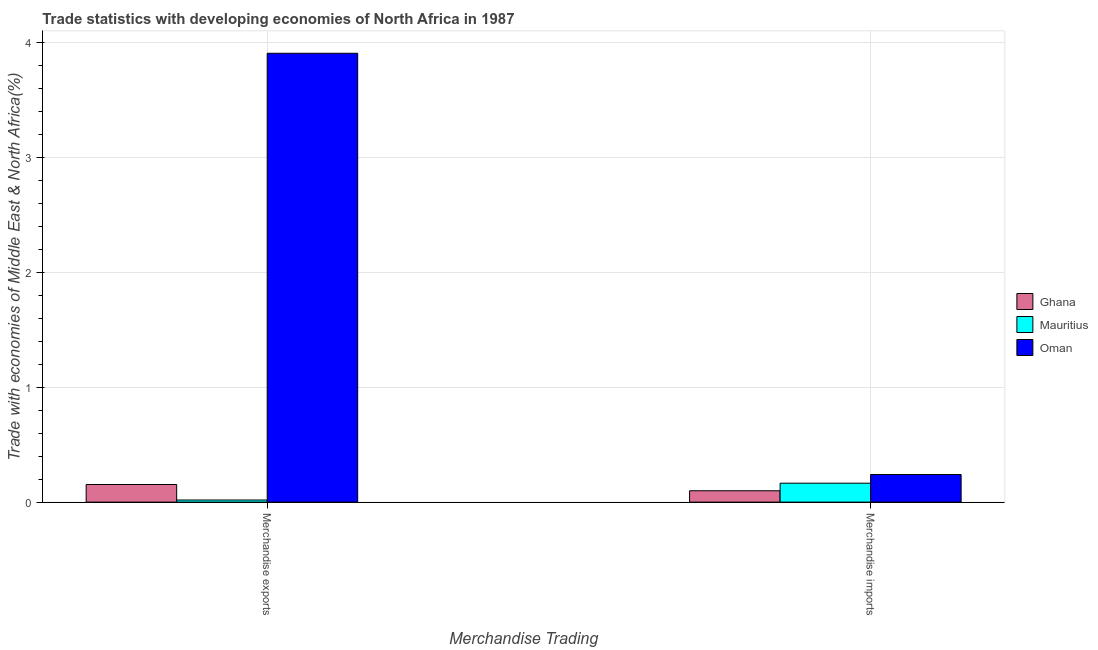How many different coloured bars are there?
Offer a very short reply. 3. Are the number of bars per tick equal to the number of legend labels?
Offer a terse response. Yes. Are the number of bars on each tick of the X-axis equal?
Keep it short and to the point. Yes. How many bars are there on the 1st tick from the left?
Provide a succinct answer. 3. How many bars are there on the 1st tick from the right?
Make the answer very short. 3. What is the merchandise imports in Oman?
Offer a terse response. 0.24. Across all countries, what is the maximum merchandise imports?
Keep it short and to the point. 0.24. Across all countries, what is the minimum merchandise exports?
Keep it short and to the point. 0.02. In which country was the merchandise imports maximum?
Keep it short and to the point. Oman. What is the total merchandise imports in the graph?
Ensure brevity in your answer.  0.5. What is the difference between the merchandise exports in Mauritius and that in Oman?
Offer a terse response. -3.89. What is the difference between the merchandise imports in Mauritius and the merchandise exports in Ghana?
Provide a succinct answer. 0.01. What is the average merchandise exports per country?
Offer a terse response. 1.36. What is the difference between the merchandise exports and merchandise imports in Ghana?
Provide a succinct answer. 0.05. What is the ratio of the merchandise exports in Mauritius to that in Oman?
Make the answer very short. 0. In how many countries, is the merchandise exports greater than the average merchandise exports taken over all countries?
Your response must be concise. 1. What does the 2nd bar from the left in Merchandise imports represents?
Your answer should be compact. Mauritius. What does the 1st bar from the right in Merchandise exports represents?
Give a very brief answer. Oman. How many bars are there?
Your response must be concise. 6. Are all the bars in the graph horizontal?
Keep it short and to the point. No. What is the difference between two consecutive major ticks on the Y-axis?
Make the answer very short. 1. Are the values on the major ticks of Y-axis written in scientific E-notation?
Offer a very short reply. No. How are the legend labels stacked?
Provide a succinct answer. Vertical. What is the title of the graph?
Ensure brevity in your answer.  Trade statistics with developing economies of North Africa in 1987. Does "Antigua and Barbuda" appear as one of the legend labels in the graph?
Give a very brief answer. No. What is the label or title of the X-axis?
Offer a terse response. Merchandise Trading. What is the label or title of the Y-axis?
Ensure brevity in your answer.  Trade with economies of Middle East & North Africa(%). What is the Trade with economies of Middle East & North Africa(%) in Ghana in Merchandise exports?
Your answer should be very brief. 0.15. What is the Trade with economies of Middle East & North Africa(%) of Mauritius in Merchandise exports?
Offer a very short reply. 0.02. What is the Trade with economies of Middle East & North Africa(%) in Oman in Merchandise exports?
Ensure brevity in your answer.  3.91. What is the Trade with economies of Middle East & North Africa(%) in Ghana in Merchandise imports?
Your answer should be compact. 0.1. What is the Trade with economies of Middle East & North Africa(%) in Mauritius in Merchandise imports?
Make the answer very short. 0.16. What is the Trade with economies of Middle East & North Africa(%) of Oman in Merchandise imports?
Your answer should be very brief. 0.24. Across all Merchandise Trading, what is the maximum Trade with economies of Middle East & North Africa(%) in Ghana?
Keep it short and to the point. 0.15. Across all Merchandise Trading, what is the maximum Trade with economies of Middle East & North Africa(%) in Mauritius?
Make the answer very short. 0.16. Across all Merchandise Trading, what is the maximum Trade with economies of Middle East & North Africa(%) in Oman?
Provide a succinct answer. 3.91. Across all Merchandise Trading, what is the minimum Trade with economies of Middle East & North Africa(%) of Ghana?
Keep it short and to the point. 0.1. Across all Merchandise Trading, what is the minimum Trade with economies of Middle East & North Africa(%) of Mauritius?
Offer a terse response. 0.02. Across all Merchandise Trading, what is the minimum Trade with economies of Middle East & North Africa(%) in Oman?
Offer a terse response. 0.24. What is the total Trade with economies of Middle East & North Africa(%) in Ghana in the graph?
Your answer should be compact. 0.25. What is the total Trade with economies of Middle East & North Africa(%) in Mauritius in the graph?
Keep it short and to the point. 0.18. What is the total Trade with economies of Middle East & North Africa(%) in Oman in the graph?
Offer a terse response. 4.15. What is the difference between the Trade with economies of Middle East & North Africa(%) in Ghana in Merchandise exports and that in Merchandise imports?
Your answer should be compact. 0.05. What is the difference between the Trade with economies of Middle East & North Africa(%) in Mauritius in Merchandise exports and that in Merchandise imports?
Offer a terse response. -0.15. What is the difference between the Trade with economies of Middle East & North Africa(%) of Oman in Merchandise exports and that in Merchandise imports?
Keep it short and to the point. 3.67. What is the difference between the Trade with economies of Middle East & North Africa(%) in Ghana in Merchandise exports and the Trade with economies of Middle East & North Africa(%) in Mauritius in Merchandise imports?
Provide a succinct answer. -0.01. What is the difference between the Trade with economies of Middle East & North Africa(%) in Ghana in Merchandise exports and the Trade with economies of Middle East & North Africa(%) in Oman in Merchandise imports?
Offer a terse response. -0.09. What is the difference between the Trade with economies of Middle East & North Africa(%) of Mauritius in Merchandise exports and the Trade with economies of Middle East & North Africa(%) of Oman in Merchandise imports?
Your answer should be very brief. -0.22. What is the average Trade with economies of Middle East & North Africa(%) of Ghana per Merchandise Trading?
Keep it short and to the point. 0.13. What is the average Trade with economies of Middle East & North Africa(%) in Mauritius per Merchandise Trading?
Keep it short and to the point. 0.09. What is the average Trade with economies of Middle East & North Africa(%) of Oman per Merchandise Trading?
Give a very brief answer. 2.07. What is the difference between the Trade with economies of Middle East & North Africa(%) in Ghana and Trade with economies of Middle East & North Africa(%) in Mauritius in Merchandise exports?
Ensure brevity in your answer.  0.14. What is the difference between the Trade with economies of Middle East & North Africa(%) in Ghana and Trade with economies of Middle East & North Africa(%) in Oman in Merchandise exports?
Offer a terse response. -3.75. What is the difference between the Trade with economies of Middle East & North Africa(%) of Mauritius and Trade with economies of Middle East & North Africa(%) of Oman in Merchandise exports?
Provide a short and direct response. -3.89. What is the difference between the Trade with economies of Middle East & North Africa(%) in Ghana and Trade with economies of Middle East & North Africa(%) in Mauritius in Merchandise imports?
Make the answer very short. -0.07. What is the difference between the Trade with economies of Middle East & North Africa(%) in Ghana and Trade with economies of Middle East & North Africa(%) in Oman in Merchandise imports?
Offer a very short reply. -0.14. What is the difference between the Trade with economies of Middle East & North Africa(%) of Mauritius and Trade with economies of Middle East & North Africa(%) of Oman in Merchandise imports?
Ensure brevity in your answer.  -0.08. What is the ratio of the Trade with economies of Middle East & North Africa(%) in Ghana in Merchandise exports to that in Merchandise imports?
Offer a very short reply. 1.55. What is the ratio of the Trade with economies of Middle East & North Africa(%) of Mauritius in Merchandise exports to that in Merchandise imports?
Provide a succinct answer. 0.11. What is the ratio of the Trade with economies of Middle East & North Africa(%) in Oman in Merchandise exports to that in Merchandise imports?
Offer a very short reply. 16.25. What is the difference between the highest and the second highest Trade with economies of Middle East & North Africa(%) of Ghana?
Your answer should be very brief. 0.05. What is the difference between the highest and the second highest Trade with economies of Middle East & North Africa(%) in Mauritius?
Offer a very short reply. 0.15. What is the difference between the highest and the second highest Trade with economies of Middle East & North Africa(%) of Oman?
Your answer should be compact. 3.67. What is the difference between the highest and the lowest Trade with economies of Middle East & North Africa(%) in Ghana?
Offer a terse response. 0.05. What is the difference between the highest and the lowest Trade with economies of Middle East & North Africa(%) in Mauritius?
Give a very brief answer. 0.15. What is the difference between the highest and the lowest Trade with economies of Middle East & North Africa(%) of Oman?
Your answer should be compact. 3.67. 